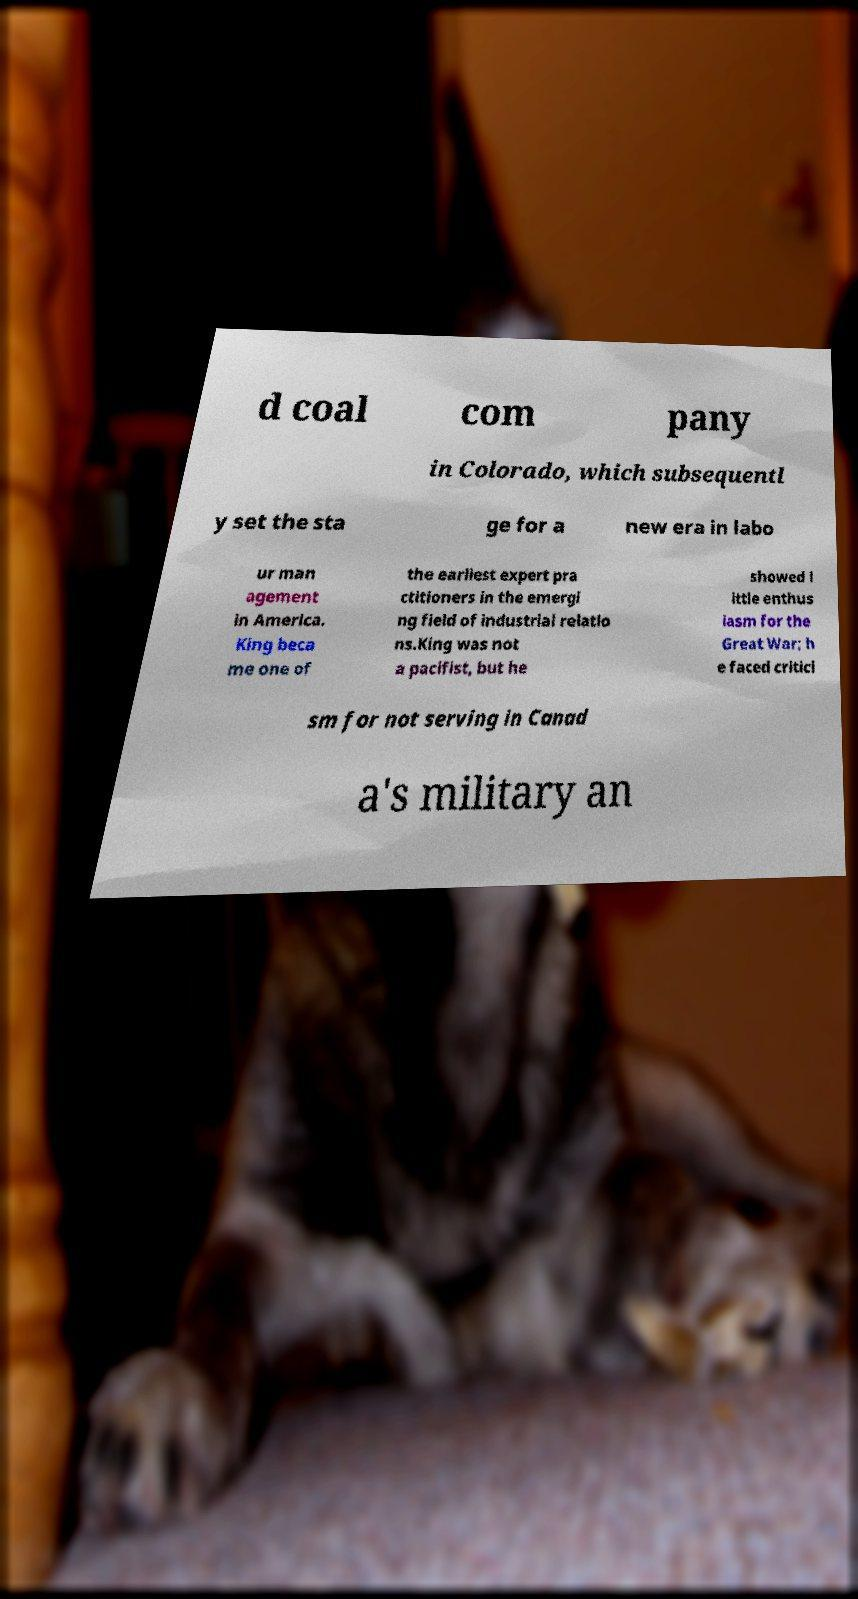Could you extract and type out the text from this image? d coal com pany in Colorado, which subsequentl y set the sta ge for a new era in labo ur man agement in America. King beca me one of the earliest expert pra ctitioners in the emergi ng field of industrial relatio ns.King was not a pacifist, but he showed l ittle enthus iasm for the Great War; h e faced critici sm for not serving in Canad a's military an 